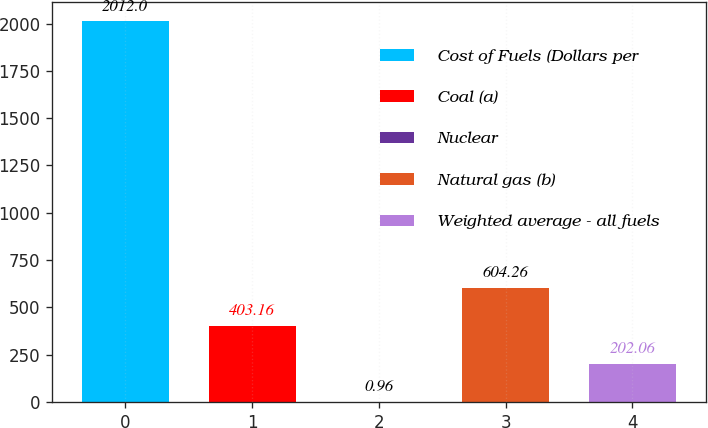Convert chart. <chart><loc_0><loc_0><loc_500><loc_500><bar_chart><fcel>Cost of Fuels (Dollars per<fcel>Coal (a)<fcel>Nuclear<fcel>Natural gas (b)<fcel>Weighted average - all fuels<nl><fcel>2012<fcel>403.16<fcel>0.96<fcel>604.26<fcel>202.06<nl></chart> 